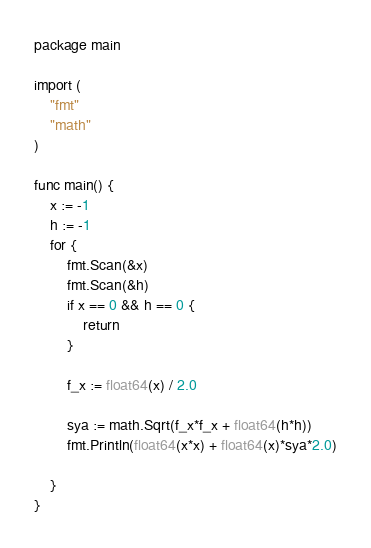<code> <loc_0><loc_0><loc_500><loc_500><_Go_>package main

import (
	"fmt"
	"math"
)

func main() {
	x := -1
	h := -1
	for {
		fmt.Scan(&x)
		fmt.Scan(&h)
		if x == 0 && h == 0 {
			return
		}

		f_x := float64(x) / 2.0

		sya := math.Sqrt(f_x*f_x + float64(h*h))
		fmt.Println(float64(x*x) + float64(x)*sya*2.0)

	}
}

</code> 